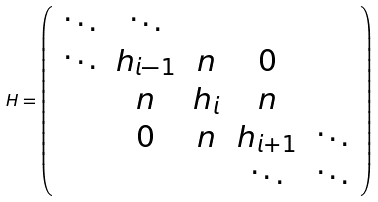Convert formula to latex. <formula><loc_0><loc_0><loc_500><loc_500>H = \left ( \begin{array} { c c c c c } \ddots & \ddots & & & \\ \ddots & h _ { i - 1 } & n & 0 & \\ & n & h _ { i } & n & \\ & 0 & n & h _ { i + 1 } & \ddots \\ & & & \ddots & \ddots \end{array} \right )</formula> 